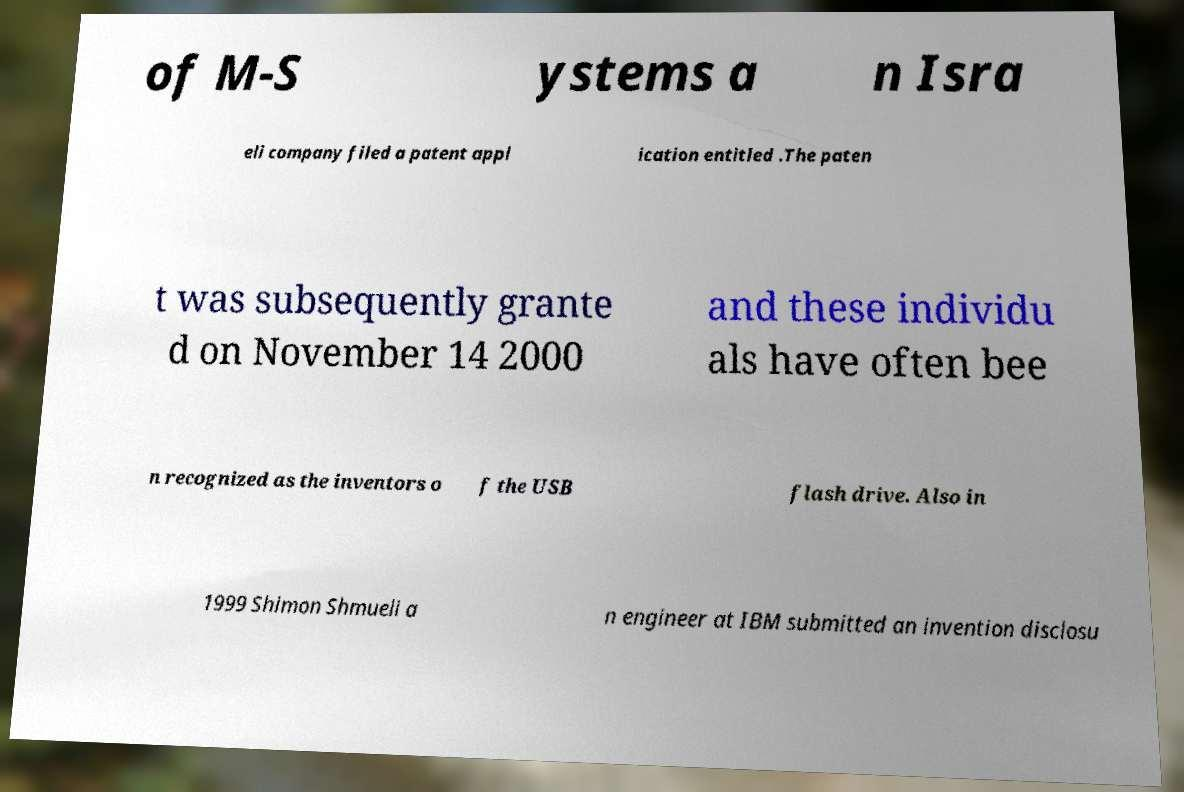For documentation purposes, I need the text within this image transcribed. Could you provide that? of M-S ystems a n Isra eli company filed a patent appl ication entitled .The paten t was subsequently grante d on November 14 2000 and these individu als have often bee n recognized as the inventors o f the USB flash drive. Also in 1999 Shimon Shmueli a n engineer at IBM submitted an invention disclosu 